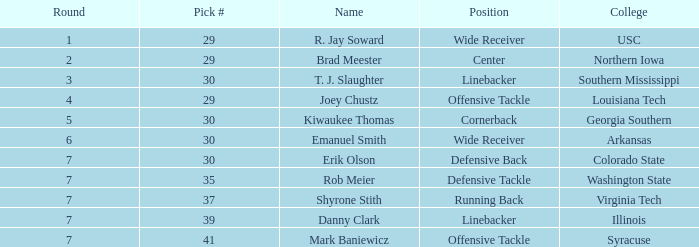Could you help me parse every detail presented in this table? {'header': ['Round', 'Pick #', 'Name', 'Position', 'College'], 'rows': [['1', '29', 'R. Jay Soward', 'Wide Receiver', 'USC'], ['2', '29', 'Brad Meester', 'Center', 'Northern Iowa'], ['3', '30', 'T. J. Slaughter', 'Linebacker', 'Southern Mississippi'], ['4', '29', 'Joey Chustz', 'Offensive Tackle', 'Louisiana Tech'], ['5', '30', 'Kiwaukee Thomas', 'Cornerback', 'Georgia Southern'], ['6', '30', 'Emanuel Smith', 'Wide Receiver', 'Arkansas'], ['7', '30', 'Erik Olson', 'Defensive Back', 'Colorado State'], ['7', '35', 'Rob Meier', 'Defensive Tackle', 'Washington State'], ['7', '37', 'Shyrone Stith', 'Running Back', 'Virginia Tech'], ['7', '39', 'Danny Clark', 'Linebacker', 'Illinois'], ['7', '41', 'Mark Baniewicz', 'Offensive Tackle', 'Syracuse']]} Which wide receiver with a 29 overall rating has the highest pick? 29.0. 